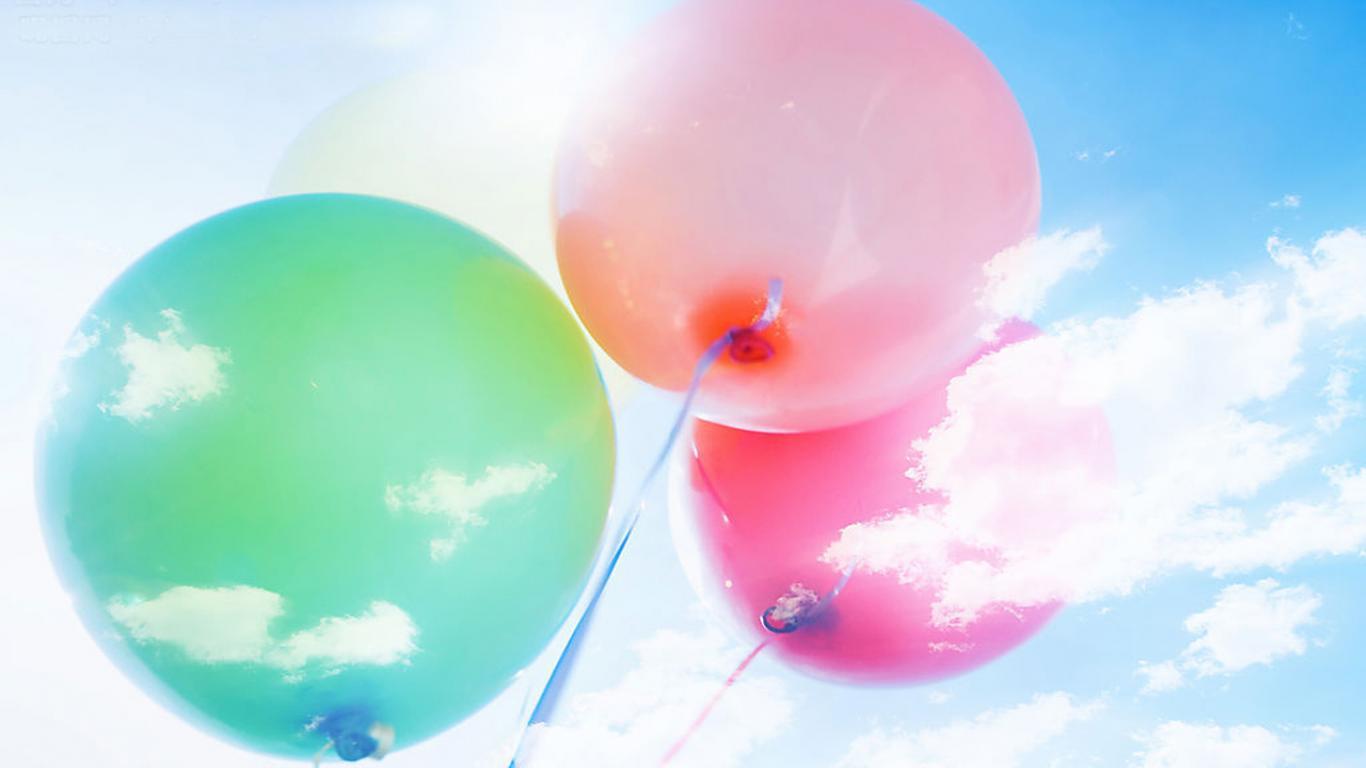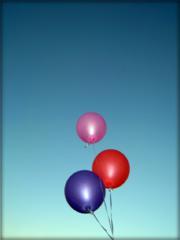The first image is the image on the left, the second image is the image on the right. For the images displayed, is the sentence "There is at least two red balloons." factually correct? Answer yes or no. No. The first image is the image on the left, the second image is the image on the right. For the images shown, is this caption "Three balloons the same color and attached to strings are in one image, while a second image shows three balloons of different colors." true? Answer yes or no. No. 